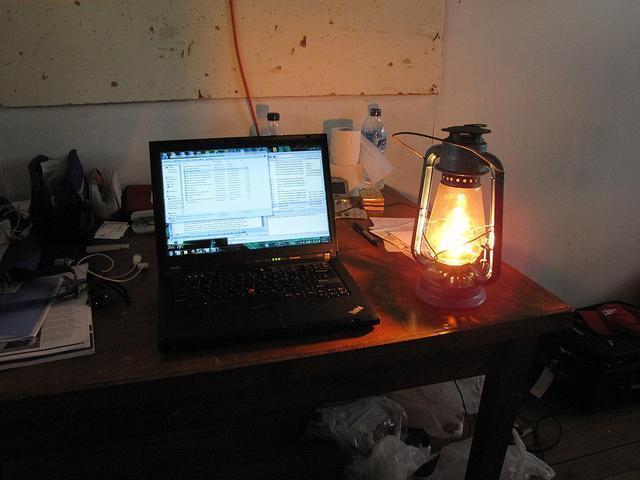What type of light source is next to the laptop?
Select the accurate answer and provide explanation: 'Answer: answer
Rationale: rationale.'
Options: Chandelier, lantern, sunlight, lamp. Answer: lantern.
Rationale: There is a glowing lantern next to the laptop. 